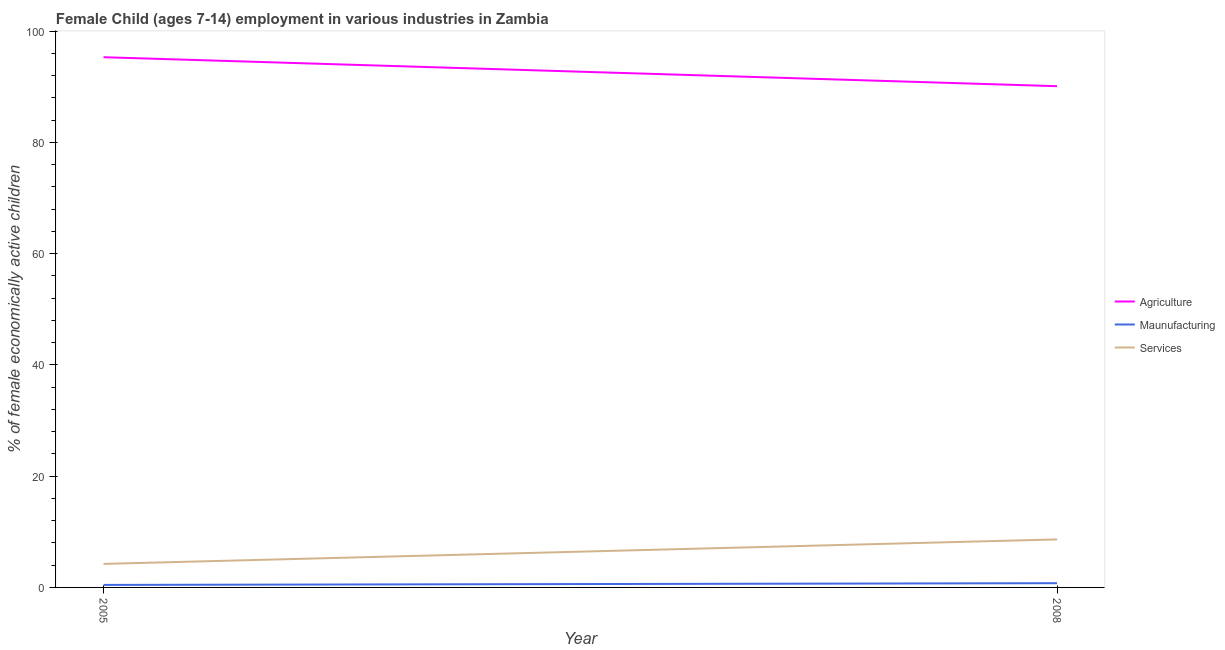How many different coloured lines are there?
Your response must be concise. 3. What is the percentage of economically active children in services in 2005?
Your answer should be compact. 4.23. Across all years, what is the maximum percentage of economically active children in services?
Keep it short and to the point. 8.63. Across all years, what is the minimum percentage of economically active children in agriculture?
Make the answer very short. 90.11. In which year was the percentage of economically active children in manufacturing minimum?
Keep it short and to the point. 2005. What is the total percentage of economically active children in manufacturing in the graph?
Your response must be concise. 1.21. What is the difference between the percentage of economically active children in manufacturing in 2005 and that in 2008?
Your response must be concise. -0.31. What is the difference between the percentage of economically active children in manufacturing in 2008 and the percentage of economically active children in agriculture in 2005?
Your answer should be compact. -94.56. What is the average percentage of economically active children in manufacturing per year?
Give a very brief answer. 0.6. In the year 2008, what is the difference between the percentage of economically active children in agriculture and percentage of economically active children in manufacturing?
Ensure brevity in your answer.  89.35. What is the ratio of the percentage of economically active children in services in 2005 to that in 2008?
Keep it short and to the point. 0.49. Is the percentage of economically active children in agriculture in 2005 less than that in 2008?
Your answer should be very brief. No. In how many years, is the percentage of economically active children in services greater than the average percentage of economically active children in services taken over all years?
Offer a terse response. 1. Does the percentage of economically active children in services monotonically increase over the years?
Offer a very short reply. Yes. Is the percentage of economically active children in manufacturing strictly greater than the percentage of economically active children in agriculture over the years?
Provide a succinct answer. No. Is the percentage of economically active children in manufacturing strictly less than the percentage of economically active children in services over the years?
Your answer should be compact. Yes. Does the graph contain grids?
Offer a very short reply. No. Where does the legend appear in the graph?
Offer a terse response. Center right. What is the title of the graph?
Provide a succinct answer. Female Child (ages 7-14) employment in various industries in Zambia. What is the label or title of the X-axis?
Your answer should be very brief. Year. What is the label or title of the Y-axis?
Ensure brevity in your answer.  % of female economically active children. What is the % of female economically active children in Agriculture in 2005?
Keep it short and to the point. 95.32. What is the % of female economically active children in Maunufacturing in 2005?
Provide a short and direct response. 0.45. What is the % of female economically active children in Services in 2005?
Your response must be concise. 4.23. What is the % of female economically active children in Agriculture in 2008?
Provide a succinct answer. 90.11. What is the % of female economically active children in Maunufacturing in 2008?
Provide a short and direct response. 0.76. What is the % of female economically active children of Services in 2008?
Offer a terse response. 8.63. Across all years, what is the maximum % of female economically active children of Agriculture?
Provide a short and direct response. 95.32. Across all years, what is the maximum % of female economically active children of Maunufacturing?
Ensure brevity in your answer.  0.76. Across all years, what is the maximum % of female economically active children of Services?
Give a very brief answer. 8.63. Across all years, what is the minimum % of female economically active children of Agriculture?
Keep it short and to the point. 90.11. Across all years, what is the minimum % of female economically active children of Maunufacturing?
Ensure brevity in your answer.  0.45. Across all years, what is the minimum % of female economically active children of Services?
Offer a terse response. 4.23. What is the total % of female economically active children in Agriculture in the graph?
Keep it short and to the point. 185.43. What is the total % of female economically active children in Maunufacturing in the graph?
Provide a short and direct response. 1.21. What is the total % of female economically active children of Services in the graph?
Make the answer very short. 12.86. What is the difference between the % of female economically active children of Agriculture in 2005 and that in 2008?
Offer a very short reply. 5.21. What is the difference between the % of female economically active children in Maunufacturing in 2005 and that in 2008?
Ensure brevity in your answer.  -0.31. What is the difference between the % of female economically active children in Agriculture in 2005 and the % of female economically active children in Maunufacturing in 2008?
Ensure brevity in your answer.  94.56. What is the difference between the % of female economically active children in Agriculture in 2005 and the % of female economically active children in Services in 2008?
Keep it short and to the point. 86.69. What is the difference between the % of female economically active children in Maunufacturing in 2005 and the % of female economically active children in Services in 2008?
Offer a very short reply. -8.18. What is the average % of female economically active children of Agriculture per year?
Provide a short and direct response. 92.72. What is the average % of female economically active children in Maunufacturing per year?
Ensure brevity in your answer.  0.6. What is the average % of female economically active children of Services per year?
Make the answer very short. 6.43. In the year 2005, what is the difference between the % of female economically active children in Agriculture and % of female economically active children in Maunufacturing?
Your answer should be very brief. 94.87. In the year 2005, what is the difference between the % of female economically active children in Agriculture and % of female economically active children in Services?
Provide a succinct answer. 91.09. In the year 2005, what is the difference between the % of female economically active children of Maunufacturing and % of female economically active children of Services?
Give a very brief answer. -3.78. In the year 2008, what is the difference between the % of female economically active children of Agriculture and % of female economically active children of Maunufacturing?
Give a very brief answer. 89.35. In the year 2008, what is the difference between the % of female economically active children in Agriculture and % of female economically active children in Services?
Provide a short and direct response. 81.48. In the year 2008, what is the difference between the % of female economically active children in Maunufacturing and % of female economically active children in Services?
Make the answer very short. -7.87. What is the ratio of the % of female economically active children of Agriculture in 2005 to that in 2008?
Your answer should be very brief. 1.06. What is the ratio of the % of female economically active children of Maunufacturing in 2005 to that in 2008?
Keep it short and to the point. 0.59. What is the ratio of the % of female economically active children of Services in 2005 to that in 2008?
Your answer should be very brief. 0.49. What is the difference between the highest and the second highest % of female economically active children in Agriculture?
Offer a very short reply. 5.21. What is the difference between the highest and the second highest % of female economically active children of Maunufacturing?
Your response must be concise. 0.31. What is the difference between the highest and the second highest % of female economically active children of Services?
Your answer should be compact. 4.4. What is the difference between the highest and the lowest % of female economically active children of Agriculture?
Your answer should be compact. 5.21. What is the difference between the highest and the lowest % of female economically active children in Maunufacturing?
Provide a succinct answer. 0.31. What is the difference between the highest and the lowest % of female economically active children of Services?
Provide a succinct answer. 4.4. 